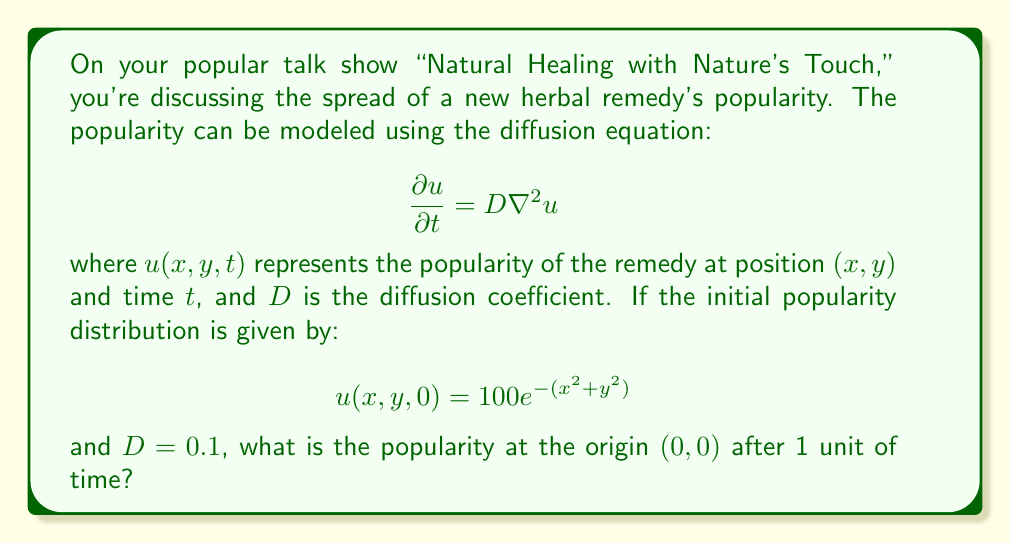Help me with this question. To solve this problem, we need to use the solution of the 2D diffusion equation with an initial Gaussian distribution. The solution for such a case is:

$$u(x,y,t) = \frac{100}{1+4Dt} \exp\left(-\frac{x^2+y^2}{1+4Dt}\right)$$

Let's break down the solution step-by-step:

1) We're interested in the popularity at the origin $(0,0)$ after 1 unit of time. So, we need to evaluate $u(0,0,1)$.

2) Substituting $x=0$, $y=0$, $t=1$, and $D=0.1$ into the solution:

   $$u(0,0,1) = \frac{100}{1+4(0.1)(1)} \exp\left(-\frac{0^2+0^2}{1+4(0.1)(1)}\right)$$

3) Simplify the denominator:
   $$u(0,0,1) = \frac{100}{1+0.4} \exp\left(-\frac{0}{1.4}\right)$$

4) Further simplification:
   $$u(0,0,1) = \frac{100}{1.4} \exp(0)$$

5) $\exp(0) = 1$, so:
   $$u(0,0,1) = \frac{100}{1.4}$$

6) Calculate the final result:
   $$u(0,0,1) = 71.4285714$$

Therefore, the popularity at the origin after 1 unit of time is approximately 71.43.
Answer: 71.43 